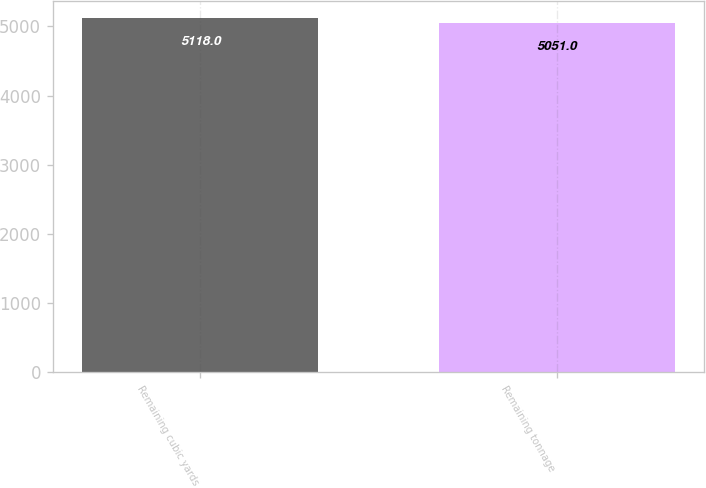Convert chart to OTSL. <chart><loc_0><loc_0><loc_500><loc_500><bar_chart><fcel>Remaining cubic yards<fcel>Remaining tonnage<nl><fcel>5118<fcel>5051<nl></chart> 